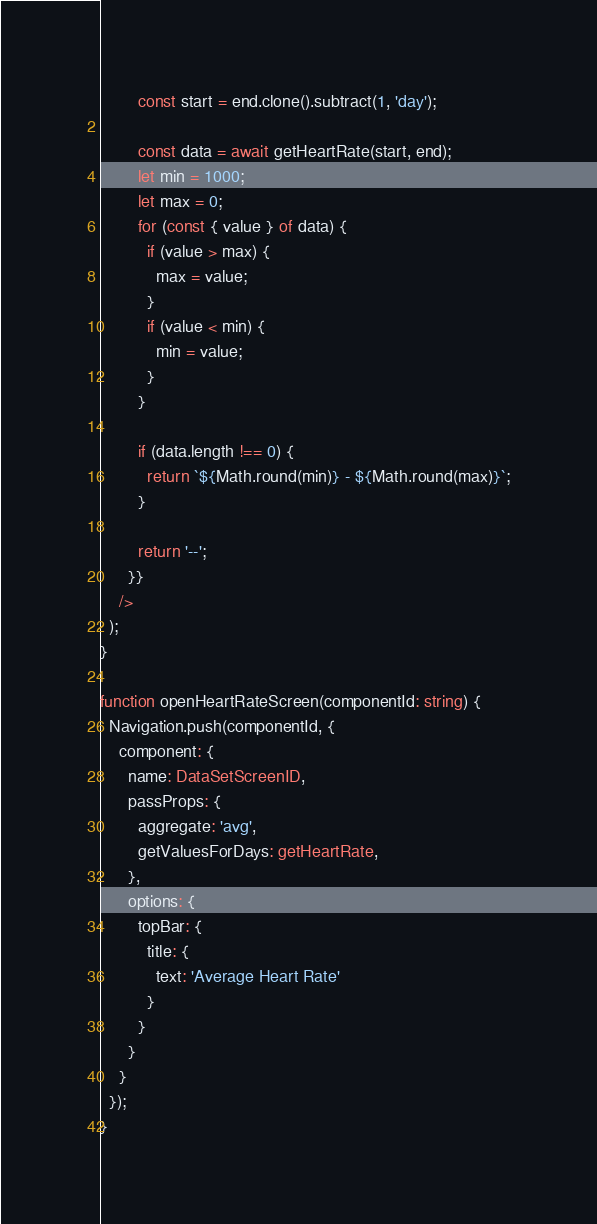<code> <loc_0><loc_0><loc_500><loc_500><_TypeScript_>        const start = end.clone().subtract(1, 'day');

        const data = await getHeartRate(start, end);
        let min = 1000;
        let max = 0;
        for (const { value } of data) {
          if (value > max) {
            max = value;
          }
          if (value < min) {
            min = value;
          }
        }

        if (data.length !== 0) {
          return `${Math.round(min)} - ${Math.round(max)}`;
        }

        return '--';
      }}
    />
  );
}

function openHeartRateScreen(componentId: string) {
  Navigation.push(componentId, {
    component: {
      name: DataSetScreenID,
      passProps: {
        aggregate: 'avg',
        getValuesForDays: getHeartRate,
      },
      options: {
        topBar: {
          title: {
            text: 'Average Heart Rate'
          }
        }
      }
    }
  });
}
</code> 